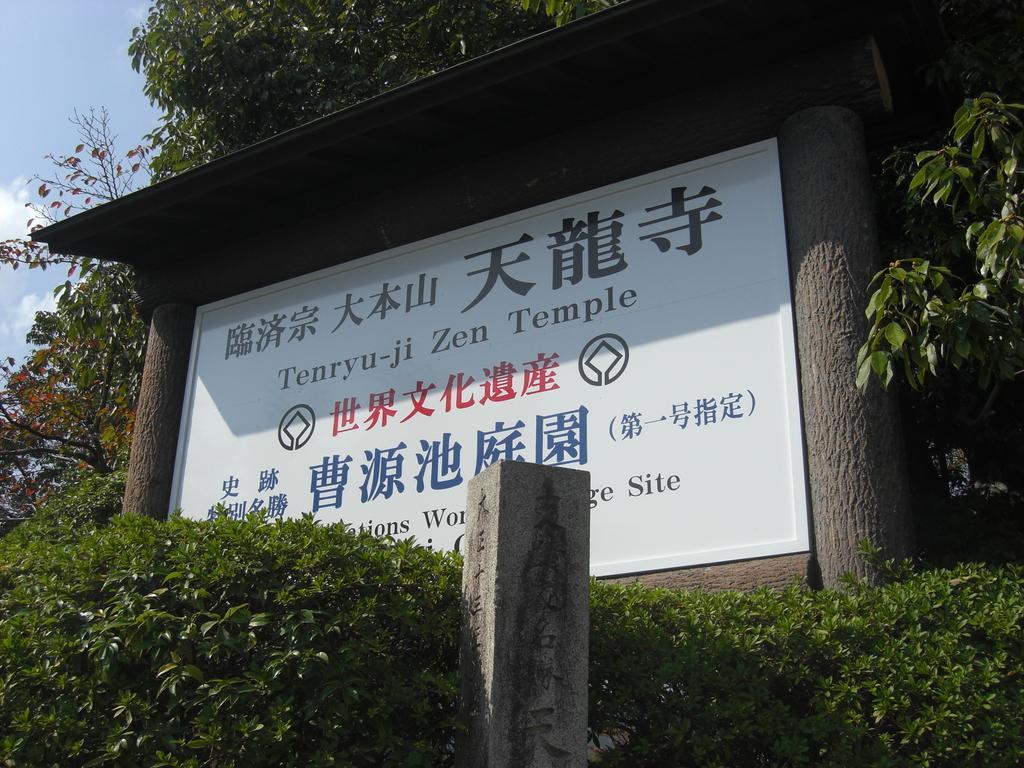Could you give a brief overview of what you see in this image? This image is taken outdoors. At the top of the image there is a sky with clouds. In the middle of the image there is a board with text on it. In the background there are many trees with green leaves. 